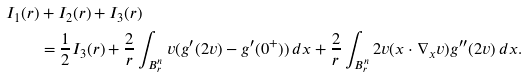Convert formula to latex. <formula><loc_0><loc_0><loc_500><loc_500>I _ { 1 } ( r ) & + I _ { 2 } ( r ) + I _ { 3 } ( r ) \\ & = \frac { 1 } { 2 } I _ { 3 } ( r ) + \frac { 2 } { r } \int _ { B ^ { n } _ { r } } v ( g ^ { \prime } ( 2 v ) - g ^ { \prime } ( 0 ^ { + } ) ) \, d x + \frac { 2 } { r } \int _ { B ^ { n } _ { r } } 2 v ( x \cdot \nabla _ { x } v ) g ^ { \prime \prime } ( 2 v ) \, d x .</formula> 